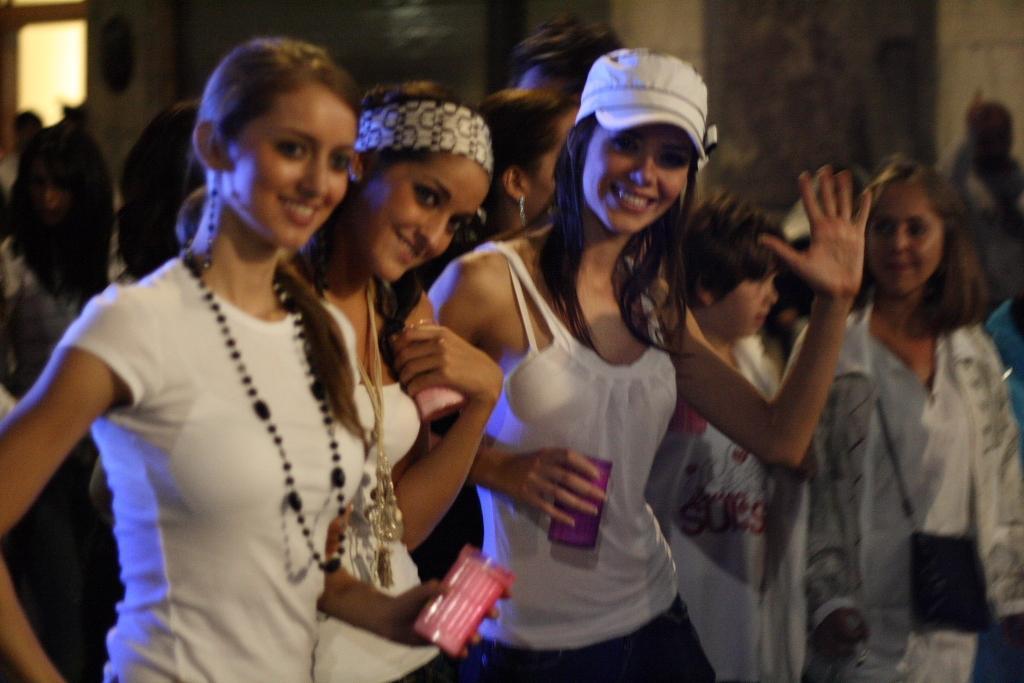How would you summarize this image in a sentence or two? This is a blur image. I can see a few people standing in the center of the image I can see three women standing and posing for the picture.  